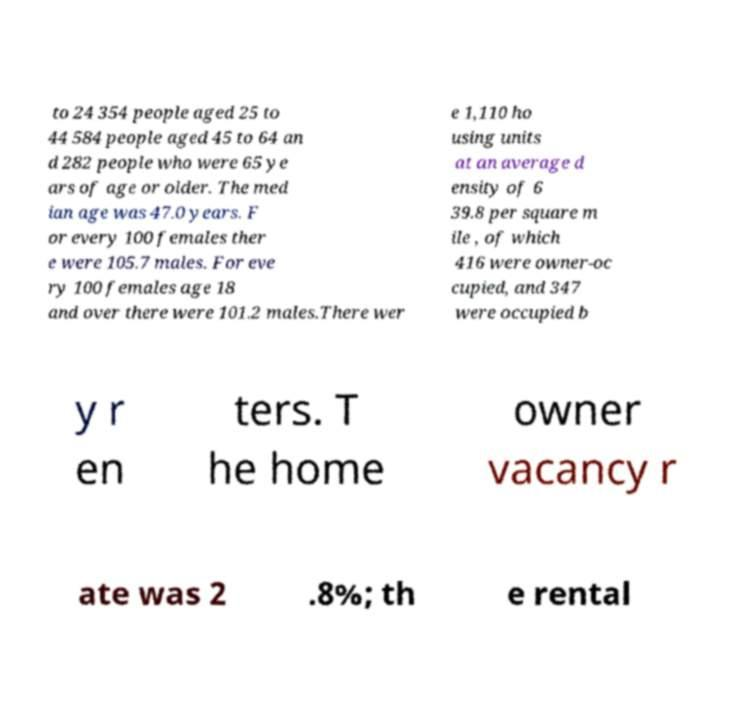Could you assist in decoding the text presented in this image and type it out clearly? to 24 354 people aged 25 to 44 584 people aged 45 to 64 an d 282 people who were 65 ye ars of age or older. The med ian age was 47.0 years. F or every 100 females ther e were 105.7 males. For eve ry 100 females age 18 and over there were 101.2 males.There wer e 1,110 ho using units at an average d ensity of 6 39.8 per square m ile , of which 416 were owner-oc cupied, and 347 were occupied b y r en ters. T he home owner vacancy r ate was 2 .8%; th e rental 